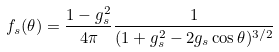Convert formula to latex. <formula><loc_0><loc_0><loc_500><loc_500>f _ { s } ( \theta ) = \frac { 1 - g _ { s } ^ { 2 } } { 4 \pi } \frac { 1 } { ( 1 + g _ { s } ^ { 2 } - 2 g _ { s } \cos { \theta } ) ^ { 3 / 2 } }</formula> 